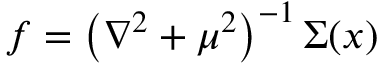<formula> <loc_0><loc_0><loc_500><loc_500>f = \left ( \nabla ^ { 2 } + \mu ^ { 2 } \right ) ^ { - 1 } \Sigma ( x )</formula> 